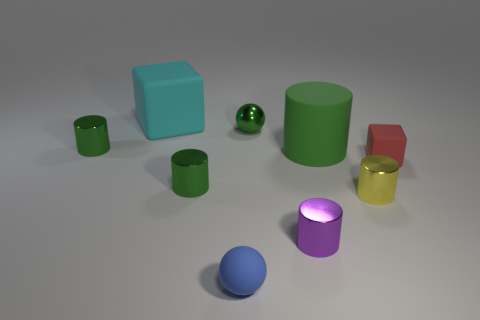There is a large thing that is the same color as the metal sphere; what is it made of?
Your answer should be compact. Rubber. What number of other objects are the same color as the large matte cylinder?
Your response must be concise. 3. Is the number of tiny metal cylinders that are right of the small blue thing the same as the number of big matte objects?
Ensure brevity in your answer.  Yes. There is a green shiny cylinder right of the large block; is there a red block behind it?
Provide a succinct answer. Yes. What size is the rubber cube that is in front of the small green thing that is behind the green metal cylinder that is behind the small red object?
Your answer should be very brief. Small. There is a cube that is behind the cube to the right of the tiny yellow cylinder; what is it made of?
Make the answer very short. Rubber. Are there any small things that have the same shape as the big cyan matte object?
Your answer should be compact. Yes. What shape is the small yellow metallic object?
Your response must be concise. Cylinder. There is a cube that is on the right side of the large rubber object that is on the right side of the matte block that is to the left of the tiny purple object; what is its material?
Give a very brief answer. Rubber. Are there more metallic cylinders left of the yellow metallic thing than blue metal cubes?
Your response must be concise. Yes. 